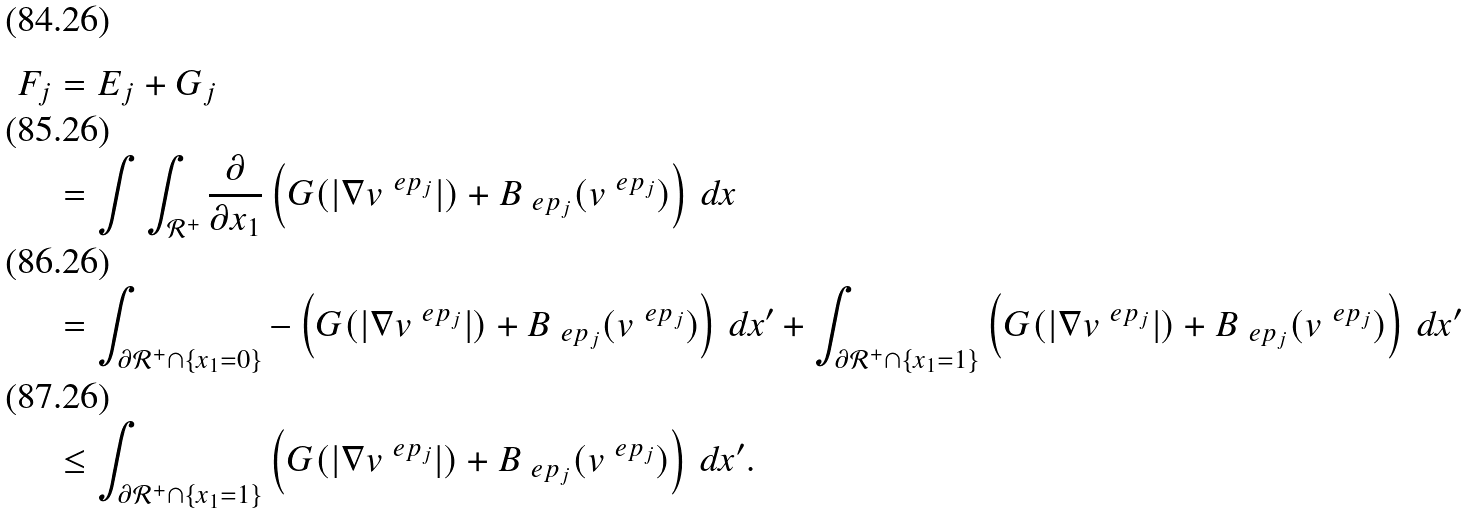Convert formula to latex. <formula><loc_0><loc_0><loc_500><loc_500>F _ { j } & = E _ { j } + G _ { j } \\ & = \int \int _ { \mathcal { R } ^ { + } } \frac { \partial } { \partial x _ { 1 } } \left ( G ( | \nabla v ^ { \ e p _ { j } } | ) + B _ { \ e p _ { j } } ( v ^ { \ e p _ { j } } ) \right ) \, d x \\ & = \int _ { \partial \mathcal { R } ^ { + } \cap \{ x _ { 1 } = 0 \} } - \left ( G ( | \nabla v ^ { \ e p _ { j } } | ) + B _ { \ e p _ { j } } ( v ^ { \ e p _ { j } } ) \right ) \, d x ^ { \prime } + \int _ { \partial \mathcal { R } ^ { + } \cap \{ x _ { 1 } = 1 \} } \left ( G ( | \nabla v ^ { \ e p _ { j } } | ) + B _ { \ e p _ { j } } ( v ^ { \ e p _ { j } } ) \right ) \, d x ^ { \prime } \\ & \leq \int _ { \partial \mathcal { R } ^ { + } \cap \{ x _ { 1 } = 1 \} } \left ( G ( | \nabla v ^ { \ e p _ { j } } | ) + B _ { \ e p _ { j } } ( v ^ { \ e p _ { j } } ) \right ) \, d x ^ { \prime } .</formula> 